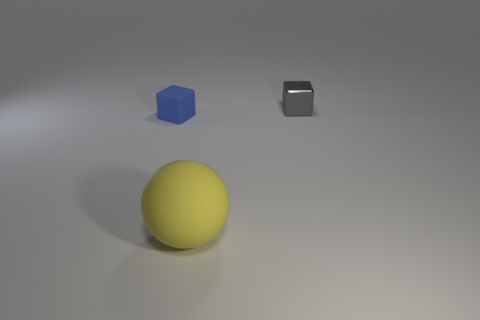Add 3 small things. How many objects exist? 6 Subtract all balls. How many objects are left? 2 Subtract 0 cyan cylinders. How many objects are left? 3 Subtract all small rubber blocks. Subtract all big yellow objects. How many objects are left? 1 Add 1 blue objects. How many blue objects are left? 2 Add 3 green shiny spheres. How many green shiny spheres exist? 3 